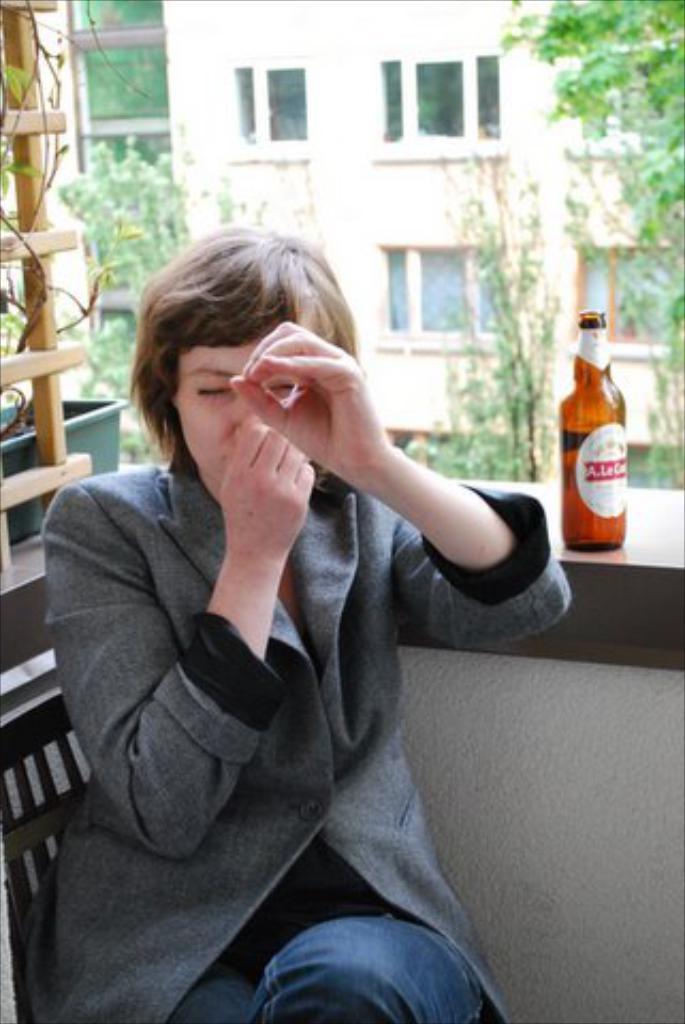Could you give a brief overview of what you see in this image? Here Is a woman wearing suit and sitting on the chair. This is the beer bottle placed on the wood. At background I can see building and trees. 